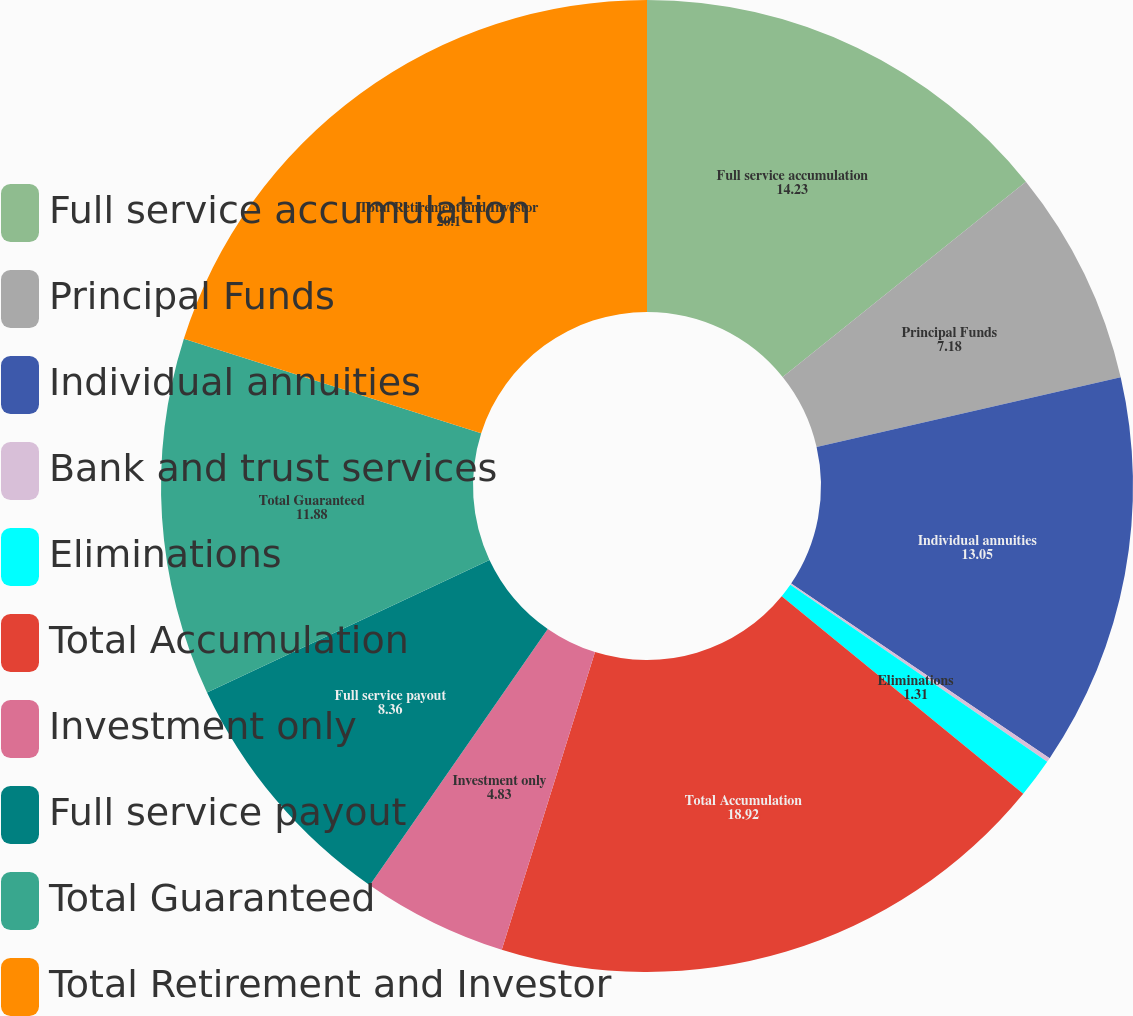Convert chart. <chart><loc_0><loc_0><loc_500><loc_500><pie_chart><fcel>Full service accumulation<fcel>Principal Funds<fcel>Individual annuities<fcel>Bank and trust services<fcel>Eliminations<fcel>Total Accumulation<fcel>Investment only<fcel>Full service payout<fcel>Total Guaranteed<fcel>Total Retirement and Investor<nl><fcel>14.23%<fcel>7.18%<fcel>13.05%<fcel>0.14%<fcel>1.31%<fcel>18.92%<fcel>4.83%<fcel>8.36%<fcel>11.88%<fcel>20.1%<nl></chart> 